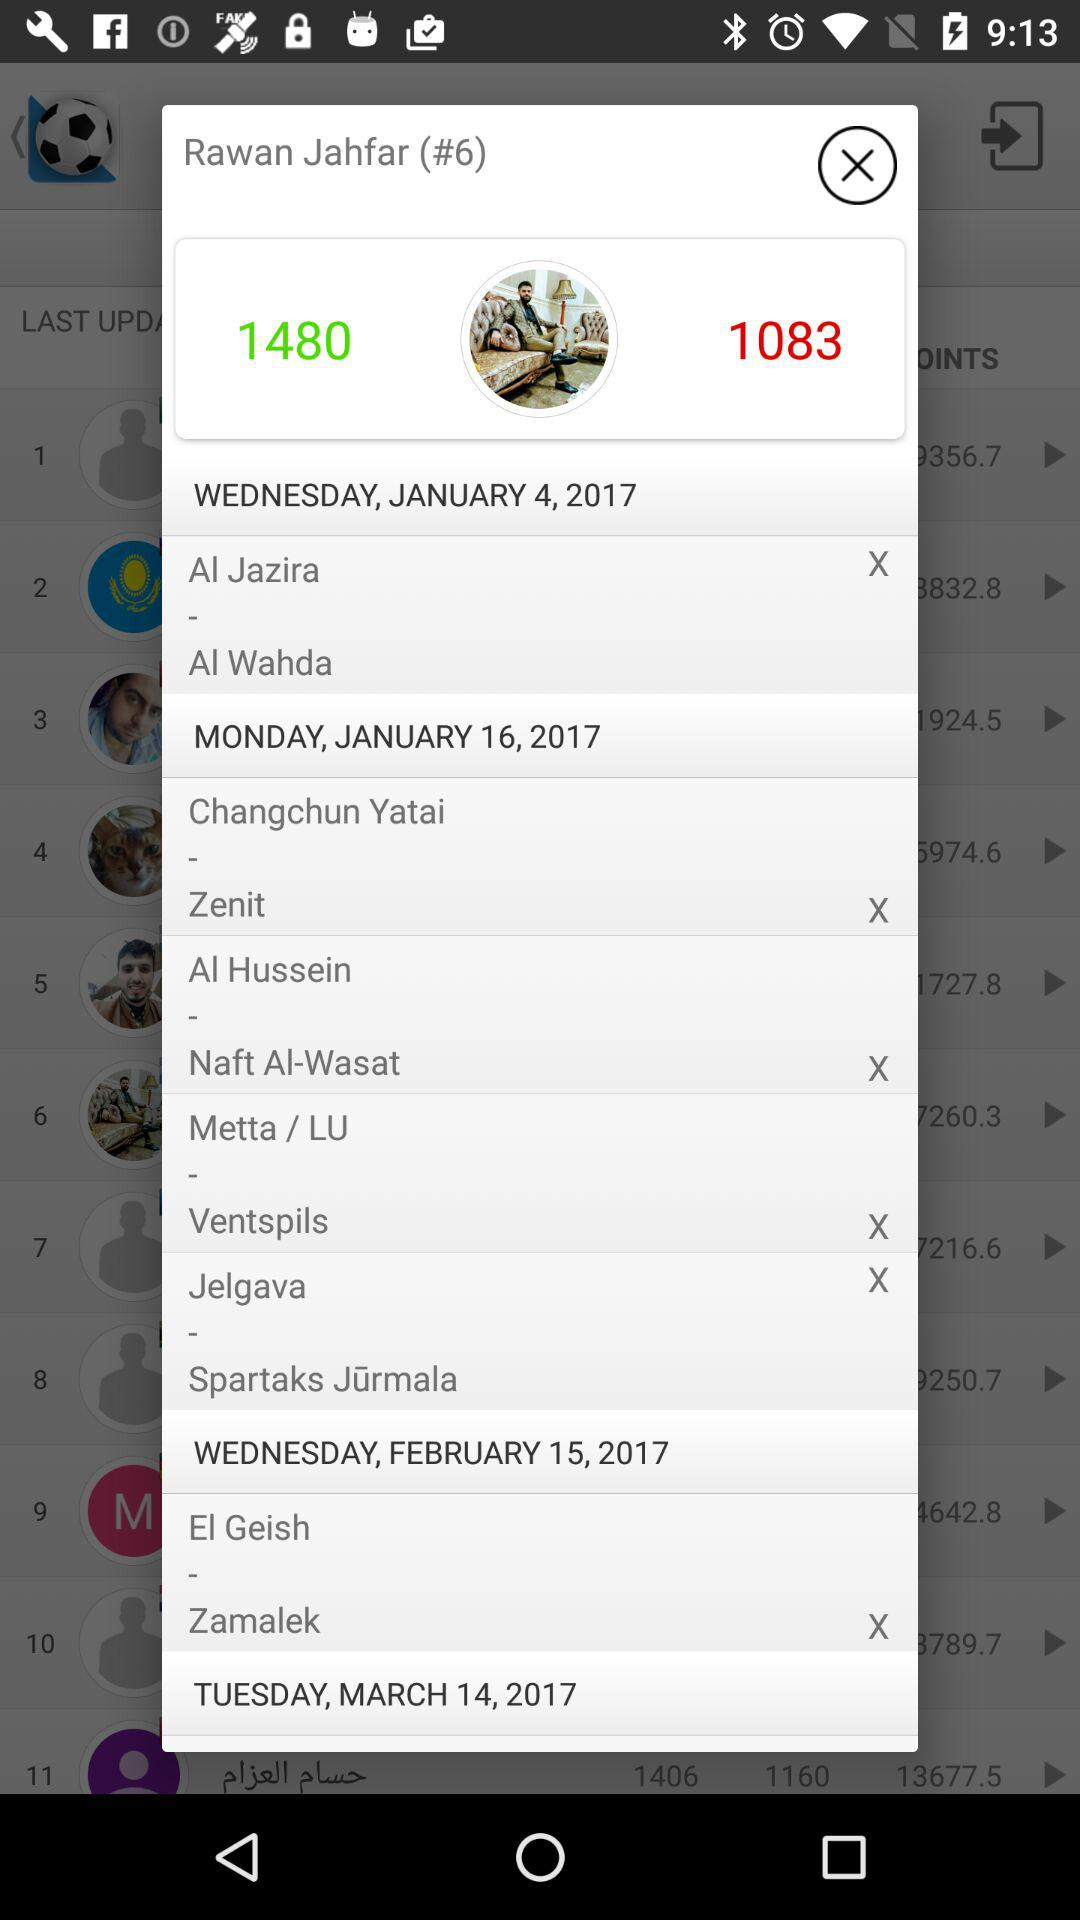Which day falls on January 4, 2017? The day is Wednesday. 